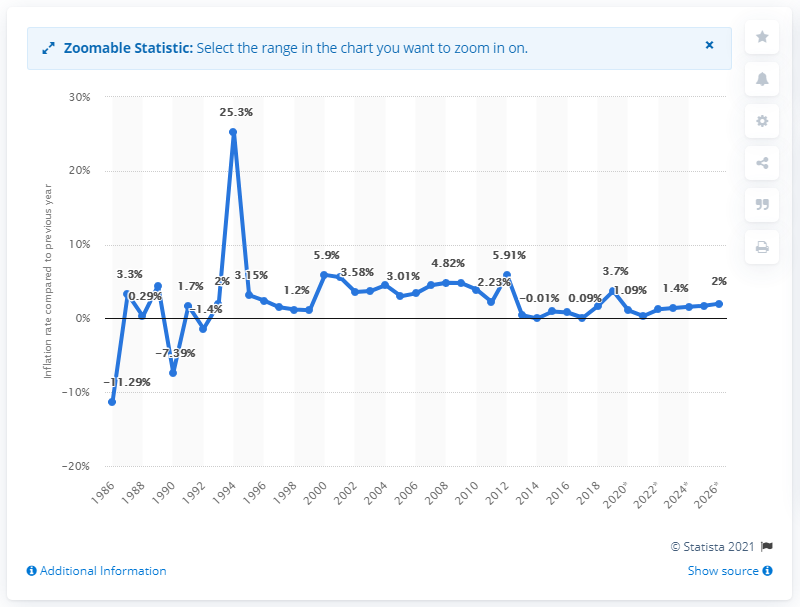What was the inflation rate in Comoros in 2019?
 3.7 